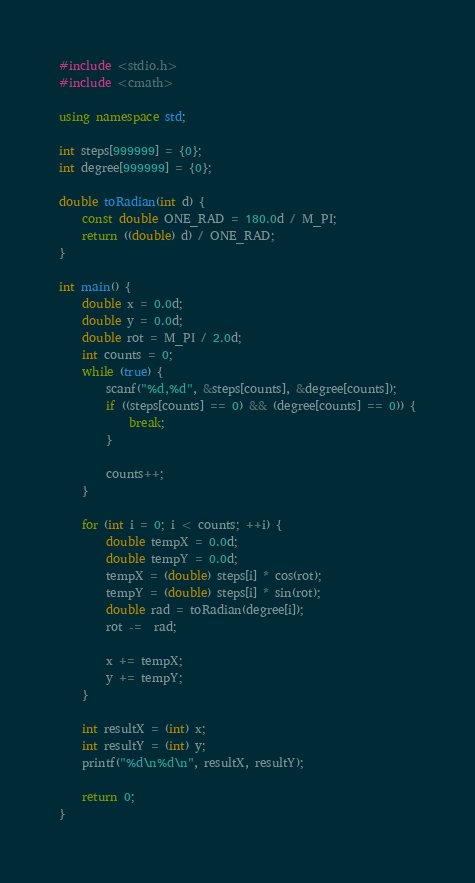Convert code to text. <code><loc_0><loc_0><loc_500><loc_500><_C++_>#include <stdio.h>
#include <cmath>

using namespace std;

int steps[999999] = {0};
int degree[999999] = {0};

double toRadian(int d) {
    const double ONE_RAD = 180.0d / M_PI;
    return ((double) d) / ONE_RAD;
}

int main() {
    double x = 0.0d;
    double y = 0.0d;
    double rot = M_PI / 2.0d;
    int counts = 0;
    while (true) {
        scanf("%d,%d", &steps[counts], &degree[counts]);
        if ((steps[counts] == 0) && (degree[counts] == 0)) {
            break;
        }

        counts++;
    }

    for (int i = 0; i < counts; ++i) {
        double tempX = 0.0d;
        double tempY = 0.0d;
        tempX = (double) steps[i] * cos(rot);
        tempY = (double) steps[i] * sin(rot);
        double rad = toRadian(degree[i]);
        rot -=  rad;

        x += tempX;
        y += tempY;
    }

    int resultX = (int) x;
    int resultY = (int) y;
    printf("%d\n%d\n", resultX, resultY);

    return 0;
}</code> 